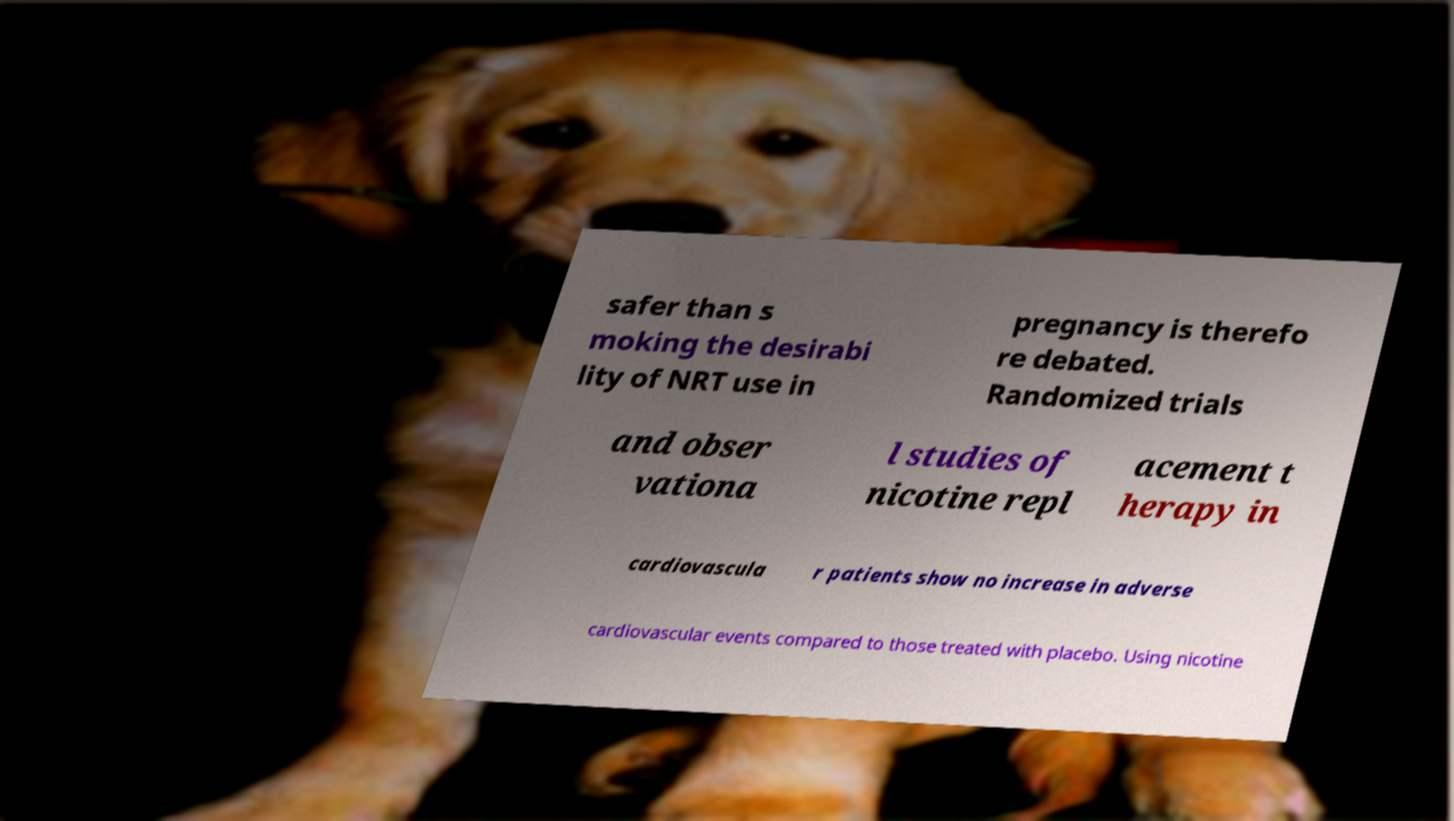Please read and relay the text visible in this image. What does it say? safer than s moking the desirabi lity of NRT use in pregnancy is therefo re debated. Randomized trials and obser vationa l studies of nicotine repl acement t herapy in cardiovascula r patients show no increase in adverse cardiovascular events compared to those treated with placebo. Using nicotine 